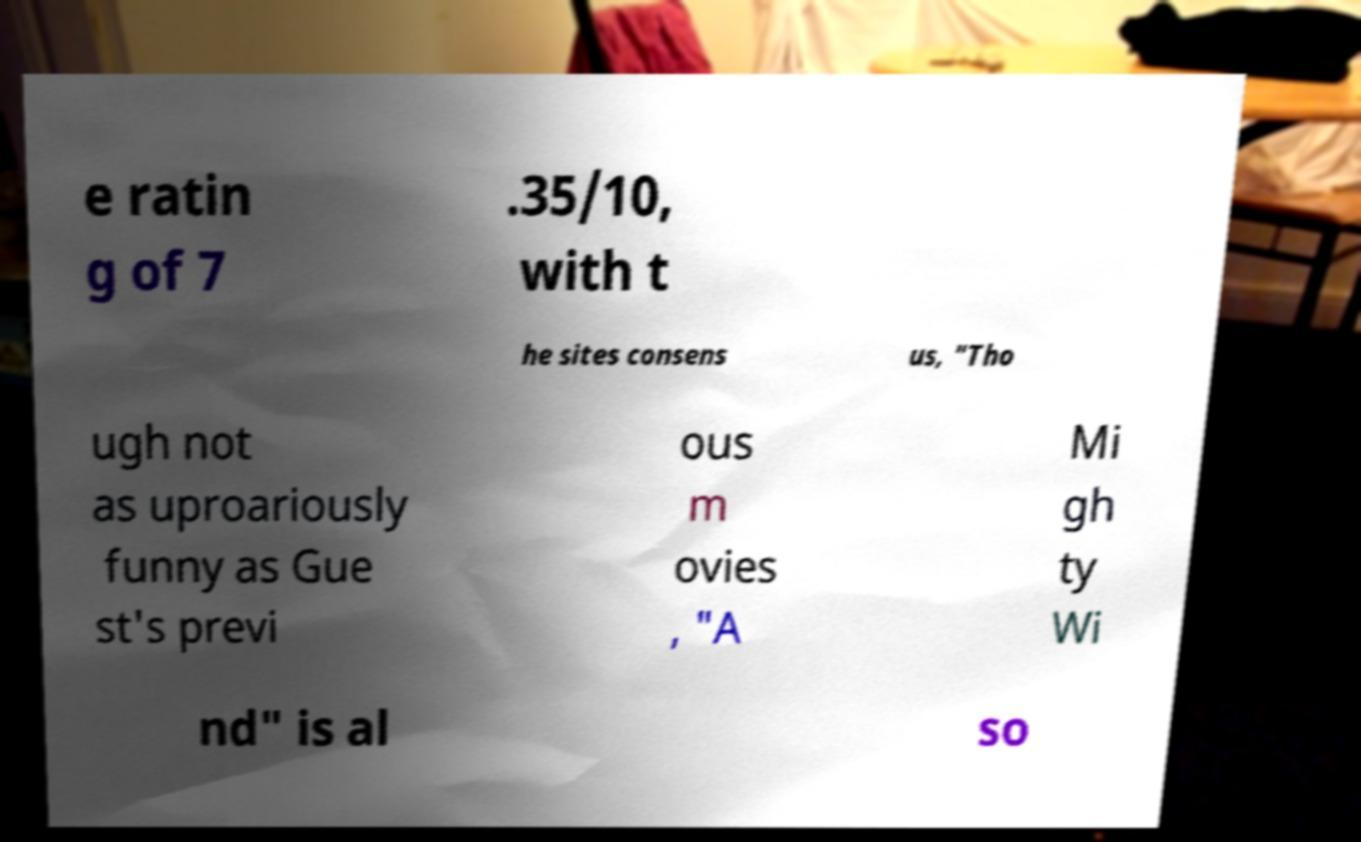Please identify and transcribe the text found in this image. e ratin g of 7 .35/10, with t he sites consens us, "Tho ugh not as uproariously funny as Gue st's previ ous m ovies , "A Mi gh ty Wi nd" is al so 